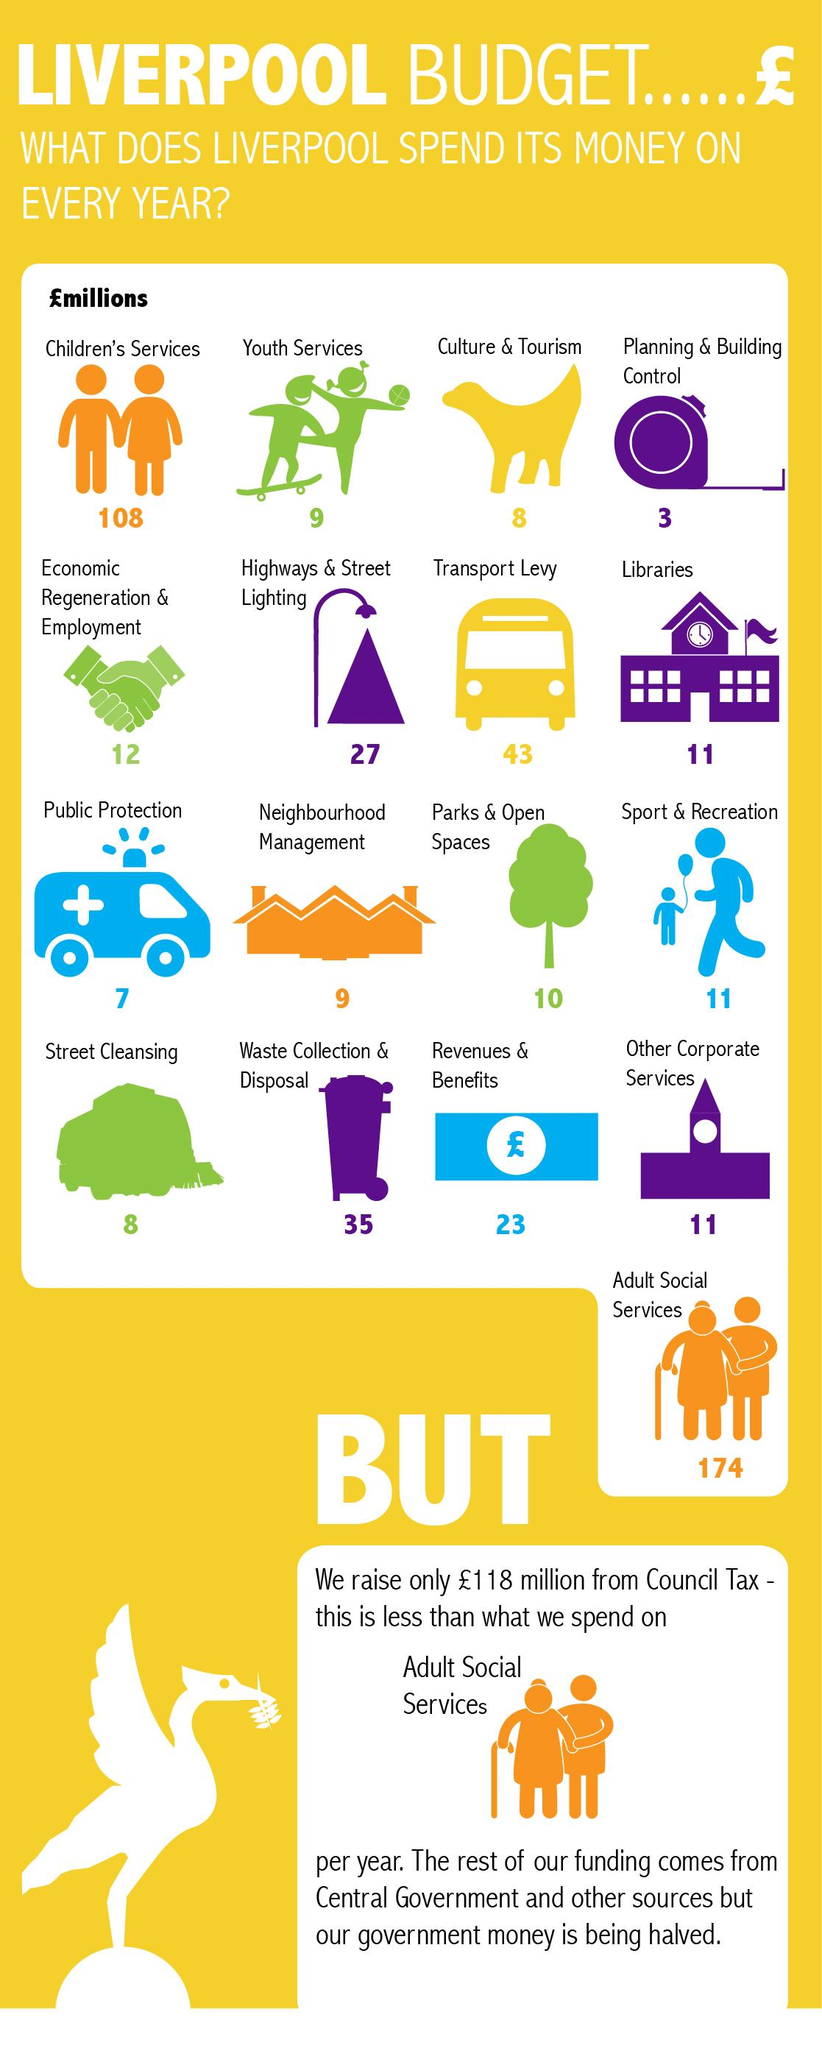Highlight a few significant elements in this photo. The Adult Social Services have offered the highest budget to Liverpool every year. According to recent data, Liverpool spends approximately £11 million annually on sports and recreation-related expenses. Planning & Building Control has consistently offered the lowest budget to Liverpool every year. According to a recent estimate, Liverpool spends approximately £8 million annually on culture and tourism. The amount of money spent by Liverpool on revenue and benefits per year is approximately £23 million. 